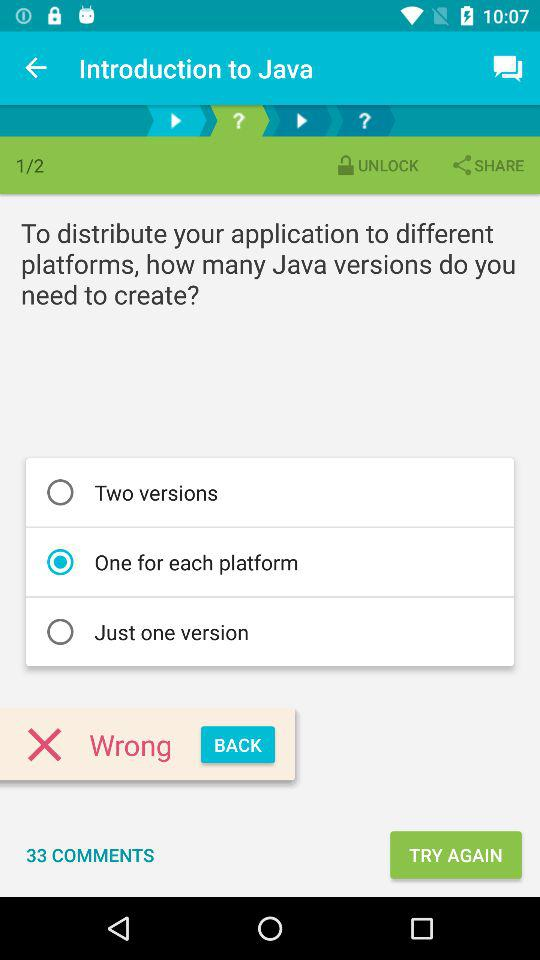Which radio button is selected? The selected radio button is "One for each platform". 